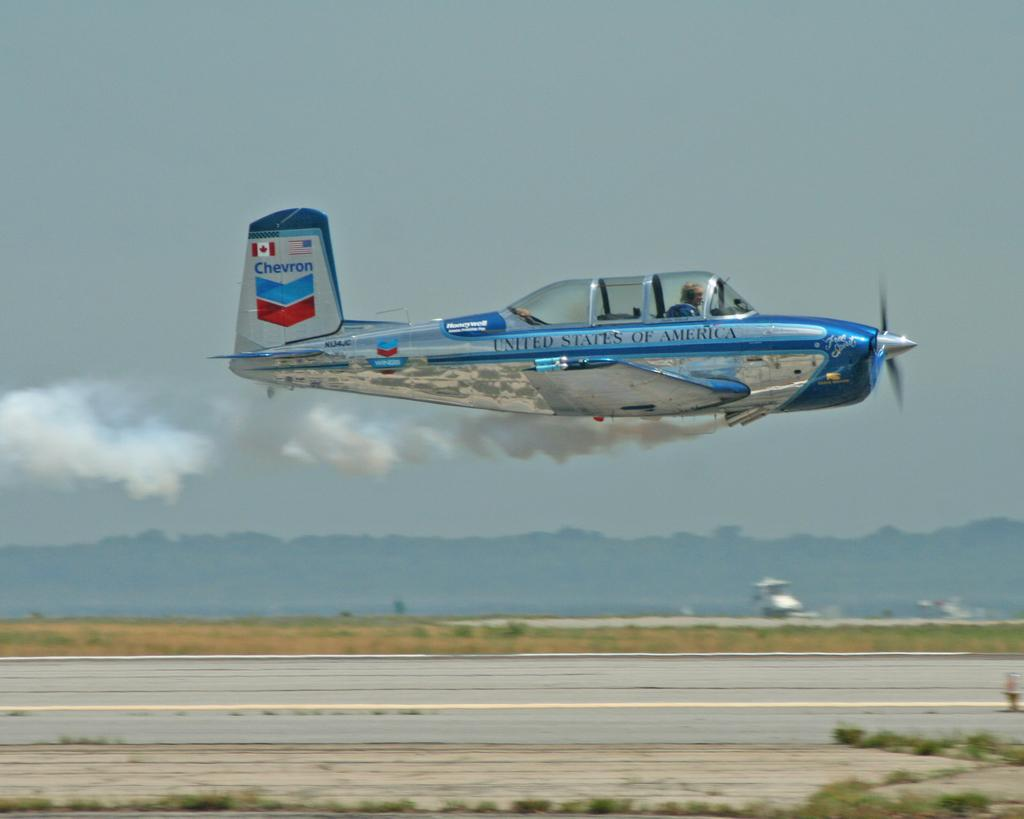What is the main subject of the image? The main subject of the image is an aircraft. What is the aircraft doing in the image? The aircraft is flying in the air. What can be seen at the bottom of the image? There is a runway at the bottom of the image. What is visible at the top of the image? The sky is visible at the top of the image. What is coming out of the aircraft in the image? The aircraft is emitting smoke. How many fish can be seen swimming in the sky in the image? There are no fish visible in the image; it features an aircraft flying in the sky. What type of apparatus is being used to drop supplies in the image? There is no apparatus or supplies being dropped in the image; it only shows an aircraft flying and emitting smoke. 